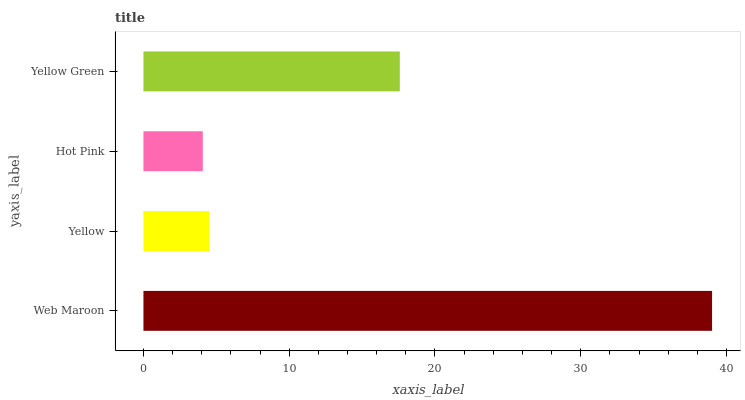Is Hot Pink the minimum?
Answer yes or no. Yes. Is Web Maroon the maximum?
Answer yes or no. Yes. Is Yellow the minimum?
Answer yes or no. No. Is Yellow the maximum?
Answer yes or no. No. Is Web Maroon greater than Yellow?
Answer yes or no. Yes. Is Yellow less than Web Maroon?
Answer yes or no. Yes. Is Yellow greater than Web Maroon?
Answer yes or no. No. Is Web Maroon less than Yellow?
Answer yes or no. No. Is Yellow Green the high median?
Answer yes or no. Yes. Is Yellow the low median?
Answer yes or no. Yes. Is Yellow the high median?
Answer yes or no. No. Is Web Maroon the low median?
Answer yes or no. No. 